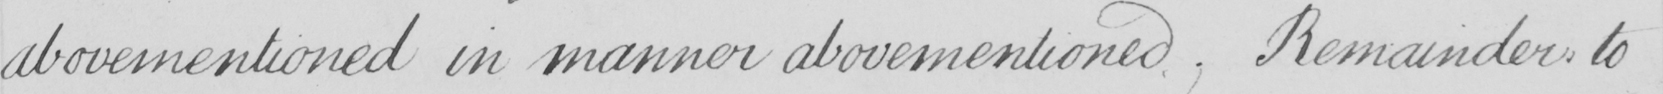Transcribe the text shown in this historical manuscript line. abovementioned in manner abovementioned  , Remainder to 